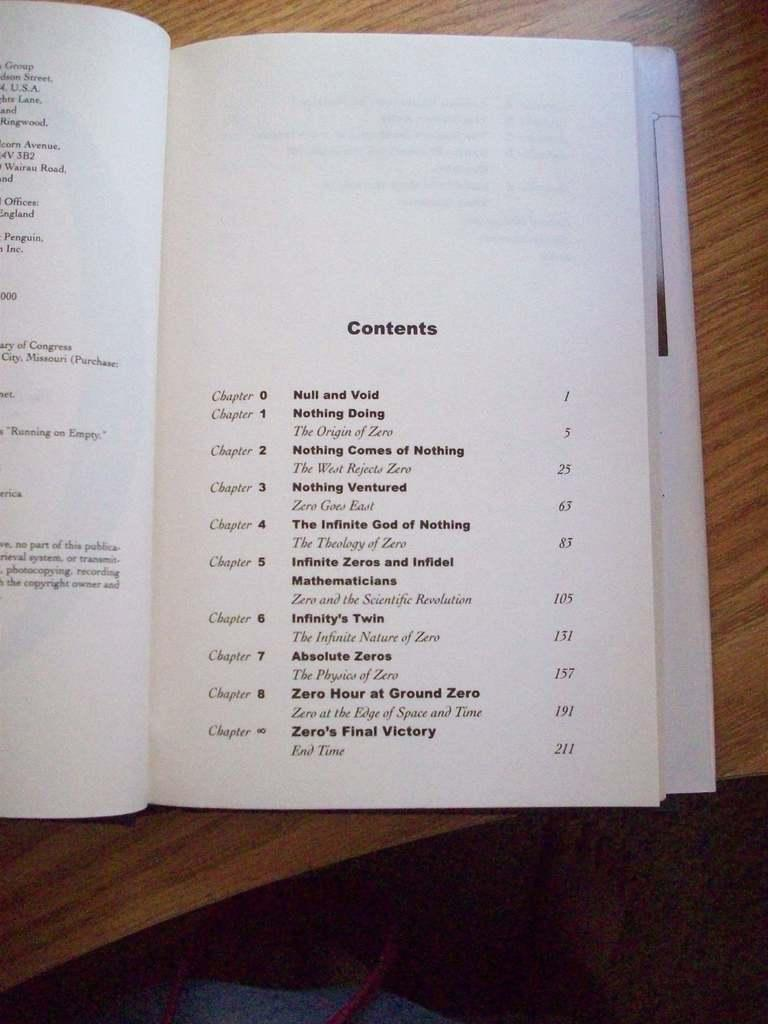<image>
Present a compact description of the photo's key features. The page shown in the book is for the contents of the book 